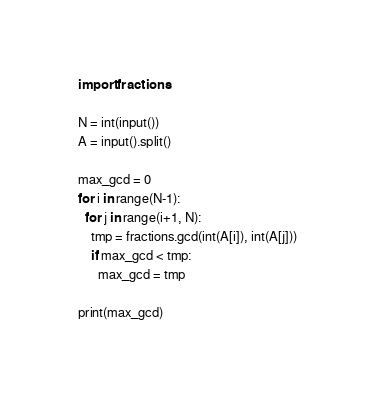Convert code to text. <code><loc_0><loc_0><loc_500><loc_500><_Python_>import fractions

N = int(input())
A = input().split()

max_gcd = 0
for i in range(N-1):
  for j in range(i+1, N):
    tmp = fractions.gcd(int(A[i]), int(A[j]))
    if max_gcd < tmp:
      max_gcd = tmp

print(max_gcd)</code> 